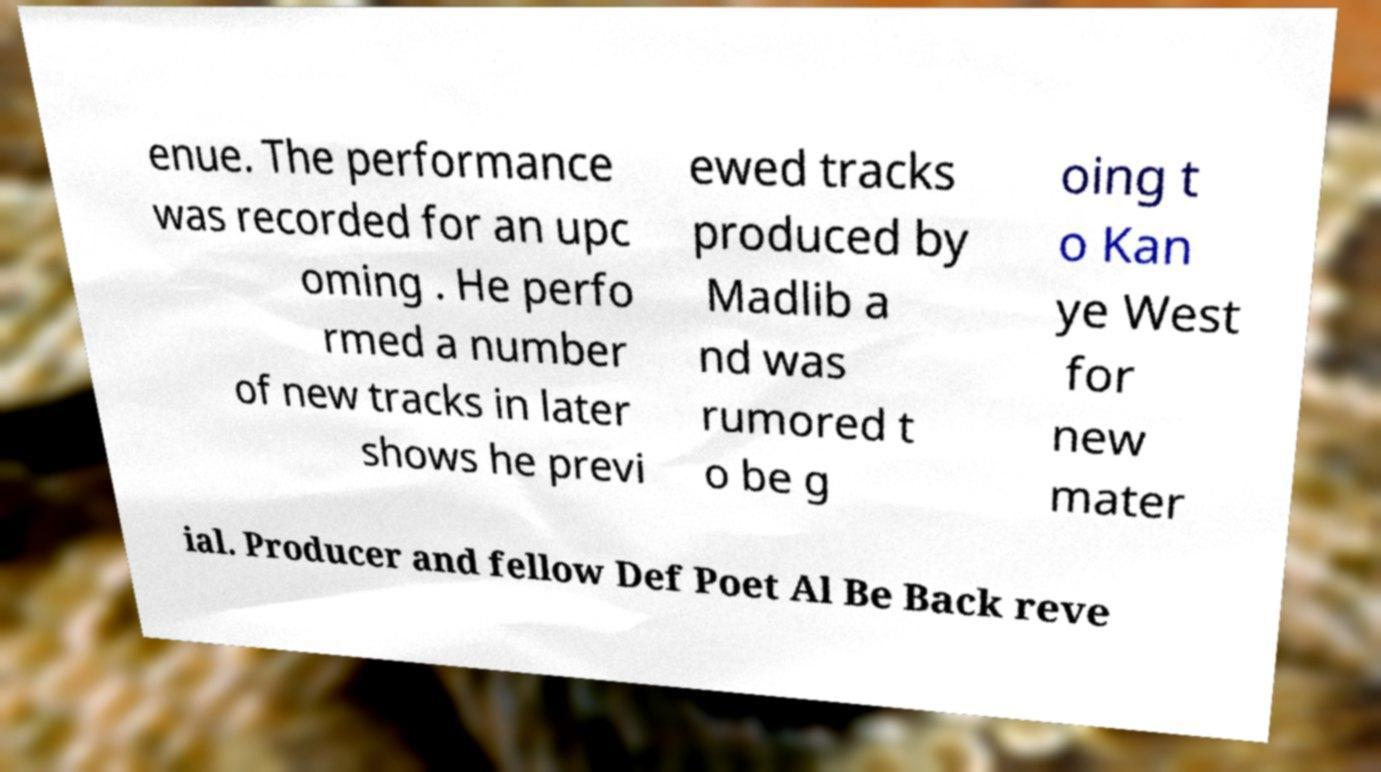There's text embedded in this image that I need extracted. Can you transcribe it verbatim? enue. The performance was recorded for an upc oming . He perfo rmed a number of new tracks in later shows he previ ewed tracks produced by Madlib a nd was rumored t o be g oing t o Kan ye West for new mater ial. Producer and fellow Def Poet Al Be Back reve 